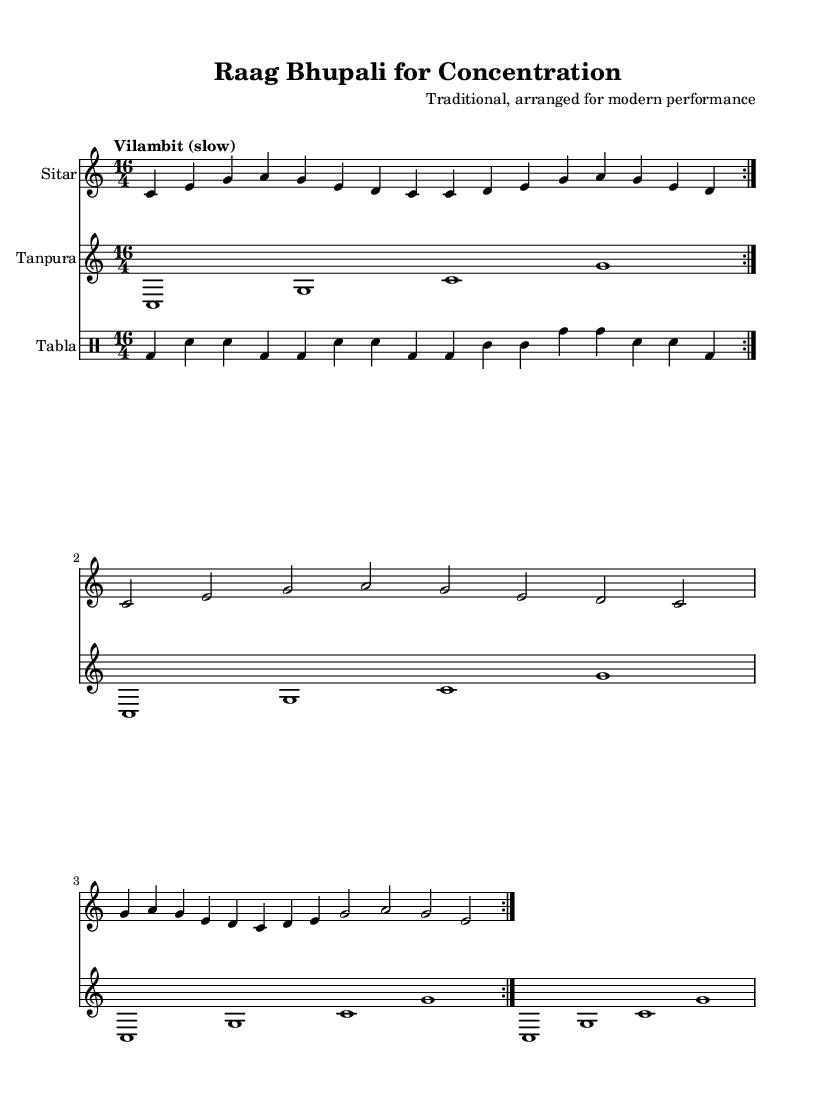What is the key signature of this music? The key signature is listed at the beginning of the score and indicates C major, which has no sharps or flats.
Answer: C major What is the time signature of this music? The time signature is found at the beginning of the score just after the key signature, which shows that the piece is in 16/4, meaning there are 16 beats in a measure.
Answer: 16/4 What is the tempo of the piece? The tempo marking is indicated above the musical staff in the score and is noted as "Vilambit (slow)" which suggests a slow pace for the performance.
Answer: Vilambit (slow) How many measures are there in the sitar part? Counting the repeated sections in the sitar part, there are a total of 8 measures repeated twice, resulting in 16 measures overall.
Answer: 16 What instruments are used in this piece? The instruments are indicated in the score as separate staves, showing three instruments: sitar, tanpura, and tabla.
Answer: Sitar, Tanpura, Tabla What musical form does the sitar part illustrate? The sitar part illustrates a repeated A-B form since it has a section that repeats, creating a structure typical in Indian classical music, where motifs are developed through repetition.
Answer: A-B form What is the role of the tanpura in this composition? The tanpura serves as a sustaining drone underneath the melodic lines, providing a tonal foundation crucial for Indian classical music and enhancing the overall atmosphere of focus.
Answer: Drone 